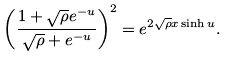<formula> <loc_0><loc_0><loc_500><loc_500>\left ( \frac { 1 + \sqrt { \rho } e ^ { - u } } { \sqrt { \rho } + e ^ { - u } } \right ) ^ { 2 } = e ^ { 2 \sqrt { \rho } x \sinh u } .</formula> 